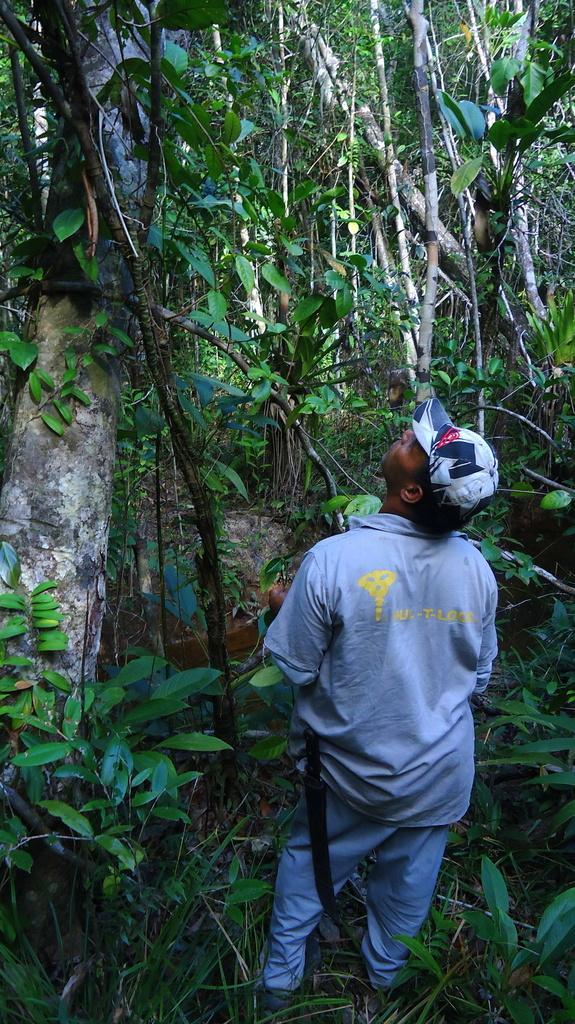What is the main subject of the image? There is a man standing in the image. What can be seen in the background of the image? There are trees in the image. What is visible at the bottom of the image? The ground is visible at the bottom of the image. What type of vegetation is present in the image? There are plants in the image. What type of trousers is the man wearing in the image? The provided facts do not mention the type of trousers the man is wearing, so we cannot answer that question. Can you tell me where the spot is located in the image? There is no spot mentioned or visible in the image. 